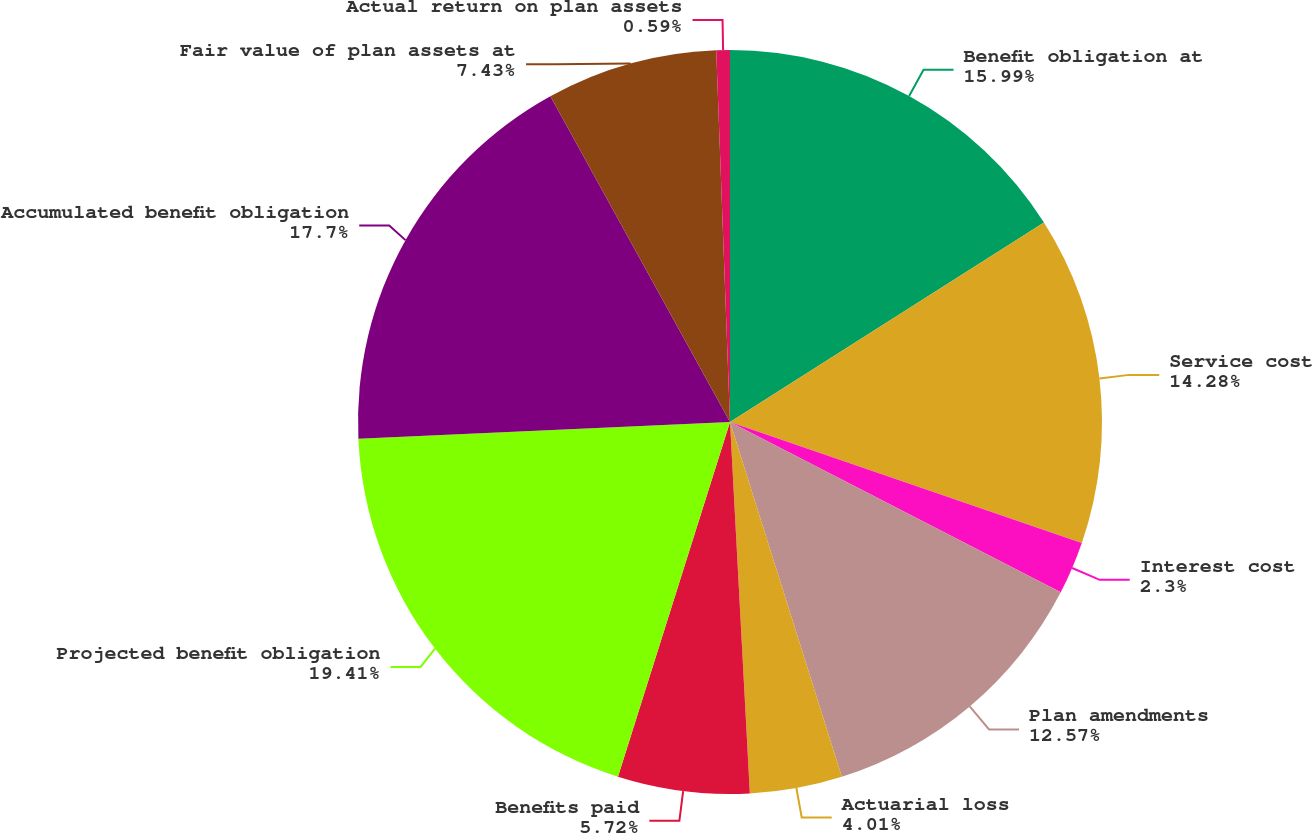<chart> <loc_0><loc_0><loc_500><loc_500><pie_chart><fcel>Benefit obligation at<fcel>Service cost<fcel>Interest cost<fcel>Plan amendments<fcel>Actuarial loss<fcel>Benefits paid<fcel>Projected benefit obligation<fcel>Accumulated benefit obligation<fcel>Fair value of plan assets at<fcel>Actual return on plan assets<nl><fcel>15.99%<fcel>14.28%<fcel>2.3%<fcel>12.57%<fcel>4.01%<fcel>5.72%<fcel>19.41%<fcel>17.7%<fcel>7.43%<fcel>0.59%<nl></chart> 